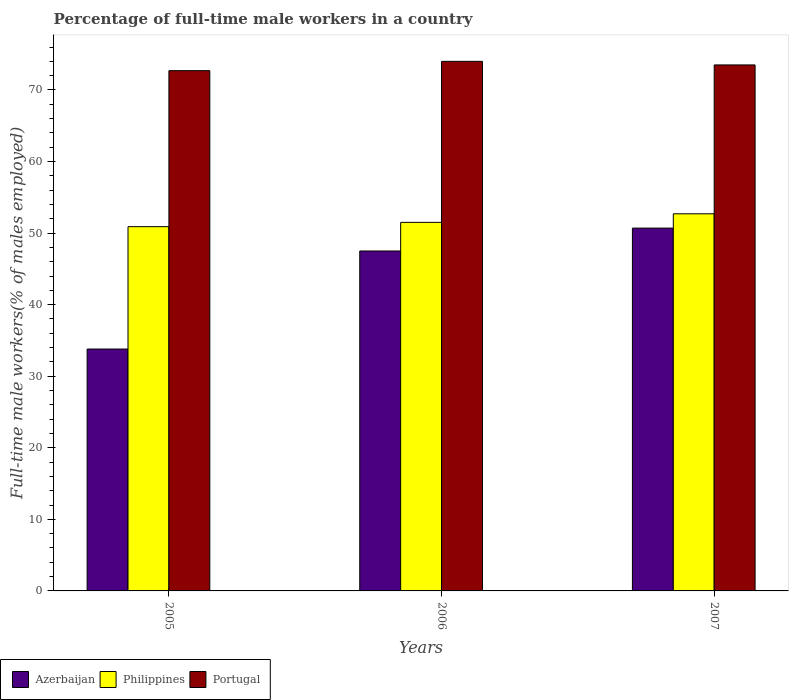Are the number of bars on each tick of the X-axis equal?
Give a very brief answer. Yes. How many bars are there on the 2nd tick from the left?
Your answer should be very brief. 3. Across all years, what is the maximum percentage of full-time male workers in Azerbaijan?
Your response must be concise. 50.7. Across all years, what is the minimum percentage of full-time male workers in Azerbaijan?
Provide a short and direct response. 33.8. In which year was the percentage of full-time male workers in Portugal minimum?
Give a very brief answer. 2005. What is the total percentage of full-time male workers in Philippines in the graph?
Provide a succinct answer. 155.1. What is the difference between the percentage of full-time male workers in Philippines in 2005 and that in 2006?
Offer a very short reply. -0.6. What is the average percentage of full-time male workers in Philippines per year?
Provide a succinct answer. 51.7. In the year 2006, what is the difference between the percentage of full-time male workers in Philippines and percentage of full-time male workers in Portugal?
Provide a succinct answer. -22.5. What is the ratio of the percentage of full-time male workers in Portugal in 2005 to that in 2006?
Offer a very short reply. 0.98. Is the difference between the percentage of full-time male workers in Philippines in 2005 and 2006 greater than the difference between the percentage of full-time male workers in Portugal in 2005 and 2006?
Ensure brevity in your answer.  Yes. What is the difference between the highest and the second highest percentage of full-time male workers in Portugal?
Ensure brevity in your answer.  0.5. What is the difference between the highest and the lowest percentage of full-time male workers in Azerbaijan?
Give a very brief answer. 16.9. What does the 3rd bar from the right in 2006 represents?
Make the answer very short. Azerbaijan. What is the difference between two consecutive major ticks on the Y-axis?
Offer a terse response. 10. Does the graph contain grids?
Offer a terse response. No. How are the legend labels stacked?
Offer a terse response. Horizontal. What is the title of the graph?
Ensure brevity in your answer.  Percentage of full-time male workers in a country. Does "Guyana" appear as one of the legend labels in the graph?
Keep it short and to the point. No. What is the label or title of the X-axis?
Offer a terse response. Years. What is the label or title of the Y-axis?
Ensure brevity in your answer.  Full-time male workers(% of males employed). What is the Full-time male workers(% of males employed) of Azerbaijan in 2005?
Your answer should be very brief. 33.8. What is the Full-time male workers(% of males employed) of Philippines in 2005?
Your answer should be compact. 50.9. What is the Full-time male workers(% of males employed) in Portugal in 2005?
Offer a terse response. 72.7. What is the Full-time male workers(% of males employed) in Azerbaijan in 2006?
Provide a short and direct response. 47.5. What is the Full-time male workers(% of males employed) in Philippines in 2006?
Offer a very short reply. 51.5. What is the Full-time male workers(% of males employed) in Portugal in 2006?
Keep it short and to the point. 74. What is the Full-time male workers(% of males employed) in Azerbaijan in 2007?
Your answer should be very brief. 50.7. What is the Full-time male workers(% of males employed) of Philippines in 2007?
Make the answer very short. 52.7. What is the Full-time male workers(% of males employed) in Portugal in 2007?
Your response must be concise. 73.5. Across all years, what is the maximum Full-time male workers(% of males employed) of Azerbaijan?
Make the answer very short. 50.7. Across all years, what is the maximum Full-time male workers(% of males employed) of Philippines?
Your answer should be compact. 52.7. Across all years, what is the minimum Full-time male workers(% of males employed) in Azerbaijan?
Provide a succinct answer. 33.8. Across all years, what is the minimum Full-time male workers(% of males employed) in Philippines?
Provide a short and direct response. 50.9. Across all years, what is the minimum Full-time male workers(% of males employed) of Portugal?
Provide a succinct answer. 72.7. What is the total Full-time male workers(% of males employed) of Azerbaijan in the graph?
Your answer should be compact. 132. What is the total Full-time male workers(% of males employed) in Philippines in the graph?
Keep it short and to the point. 155.1. What is the total Full-time male workers(% of males employed) of Portugal in the graph?
Provide a short and direct response. 220.2. What is the difference between the Full-time male workers(% of males employed) of Azerbaijan in 2005 and that in 2006?
Provide a succinct answer. -13.7. What is the difference between the Full-time male workers(% of males employed) in Philippines in 2005 and that in 2006?
Your response must be concise. -0.6. What is the difference between the Full-time male workers(% of males employed) in Azerbaijan in 2005 and that in 2007?
Ensure brevity in your answer.  -16.9. What is the difference between the Full-time male workers(% of males employed) in Portugal in 2005 and that in 2007?
Keep it short and to the point. -0.8. What is the difference between the Full-time male workers(% of males employed) of Philippines in 2006 and that in 2007?
Provide a succinct answer. -1.2. What is the difference between the Full-time male workers(% of males employed) of Portugal in 2006 and that in 2007?
Your response must be concise. 0.5. What is the difference between the Full-time male workers(% of males employed) in Azerbaijan in 2005 and the Full-time male workers(% of males employed) in Philippines in 2006?
Provide a succinct answer. -17.7. What is the difference between the Full-time male workers(% of males employed) of Azerbaijan in 2005 and the Full-time male workers(% of males employed) of Portugal in 2006?
Your answer should be compact. -40.2. What is the difference between the Full-time male workers(% of males employed) of Philippines in 2005 and the Full-time male workers(% of males employed) of Portugal in 2006?
Give a very brief answer. -23.1. What is the difference between the Full-time male workers(% of males employed) in Azerbaijan in 2005 and the Full-time male workers(% of males employed) in Philippines in 2007?
Your answer should be compact. -18.9. What is the difference between the Full-time male workers(% of males employed) in Azerbaijan in 2005 and the Full-time male workers(% of males employed) in Portugal in 2007?
Give a very brief answer. -39.7. What is the difference between the Full-time male workers(% of males employed) in Philippines in 2005 and the Full-time male workers(% of males employed) in Portugal in 2007?
Give a very brief answer. -22.6. What is the difference between the Full-time male workers(% of males employed) in Azerbaijan in 2006 and the Full-time male workers(% of males employed) in Philippines in 2007?
Make the answer very short. -5.2. What is the difference between the Full-time male workers(% of males employed) in Azerbaijan in 2006 and the Full-time male workers(% of males employed) in Portugal in 2007?
Your response must be concise. -26. What is the average Full-time male workers(% of males employed) in Azerbaijan per year?
Ensure brevity in your answer.  44. What is the average Full-time male workers(% of males employed) in Philippines per year?
Offer a very short reply. 51.7. What is the average Full-time male workers(% of males employed) in Portugal per year?
Your answer should be very brief. 73.4. In the year 2005, what is the difference between the Full-time male workers(% of males employed) in Azerbaijan and Full-time male workers(% of males employed) in Philippines?
Give a very brief answer. -17.1. In the year 2005, what is the difference between the Full-time male workers(% of males employed) of Azerbaijan and Full-time male workers(% of males employed) of Portugal?
Provide a succinct answer. -38.9. In the year 2005, what is the difference between the Full-time male workers(% of males employed) in Philippines and Full-time male workers(% of males employed) in Portugal?
Your response must be concise. -21.8. In the year 2006, what is the difference between the Full-time male workers(% of males employed) of Azerbaijan and Full-time male workers(% of males employed) of Portugal?
Your answer should be very brief. -26.5. In the year 2006, what is the difference between the Full-time male workers(% of males employed) of Philippines and Full-time male workers(% of males employed) of Portugal?
Your answer should be compact. -22.5. In the year 2007, what is the difference between the Full-time male workers(% of males employed) in Azerbaijan and Full-time male workers(% of males employed) in Portugal?
Your answer should be compact. -22.8. In the year 2007, what is the difference between the Full-time male workers(% of males employed) in Philippines and Full-time male workers(% of males employed) in Portugal?
Provide a succinct answer. -20.8. What is the ratio of the Full-time male workers(% of males employed) in Azerbaijan in 2005 to that in 2006?
Your response must be concise. 0.71. What is the ratio of the Full-time male workers(% of males employed) of Philippines in 2005 to that in 2006?
Your answer should be compact. 0.99. What is the ratio of the Full-time male workers(% of males employed) of Portugal in 2005 to that in 2006?
Offer a very short reply. 0.98. What is the ratio of the Full-time male workers(% of males employed) of Azerbaijan in 2005 to that in 2007?
Give a very brief answer. 0.67. What is the ratio of the Full-time male workers(% of males employed) in Philippines in 2005 to that in 2007?
Offer a terse response. 0.97. What is the ratio of the Full-time male workers(% of males employed) of Portugal in 2005 to that in 2007?
Make the answer very short. 0.99. What is the ratio of the Full-time male workers(% of males employed) of Azerbaijan in 2006 to that in 2007?
Keep it short and to the point. 0.94. What is the ratio of the Full-time male workers(% of males employed) in Philippines in 2006 to that in 2007?
Provide a succinct answer. 0.98. What is the ratio of the Full-time male workers(% of males employed) in Portugal in 2006 to that in 2007?
Your response must be concise. 1.01. What is the difference between the highest and the second highest Full-time male workers(% of males employed) in Philippines?
Provide a succinct answer. 1.2. 